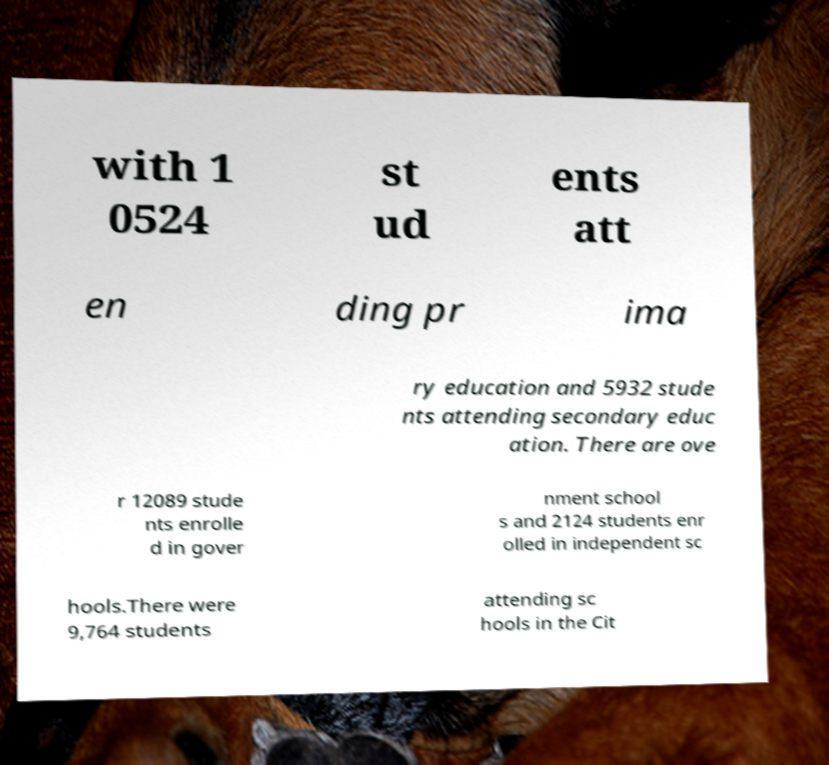For documentation purposes, I need the text within this image transcribed. Could you provide that? with 1 0524 st ud ents att en ding pr ima ry education and 5932 stude nts attending secondary educ ation. There are ove r 12089 stude nts enrolle d in gover nment school s and 2124 students enr olled in independent sc hools.There were 9,764 students attending sc hools in the Cit 